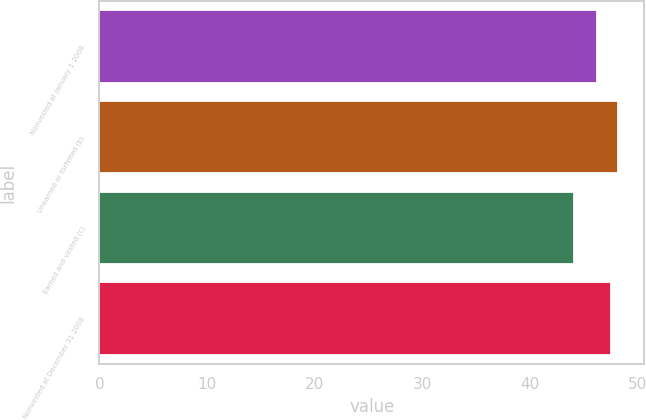Convert chart to OTSL. <chart><loc_0><loc_0><loc_500><loc_500><bar_chart><fcel>Nonvested at January 1 2008<fcel>Unearned or forfeited (b)<fcel>Earned and vested (c)<fcel>Nonvested at December 31 2008<nl><fcel>46.23<fcel>48.19<fcel>44.05<fcel>47.46<nl></chart> 